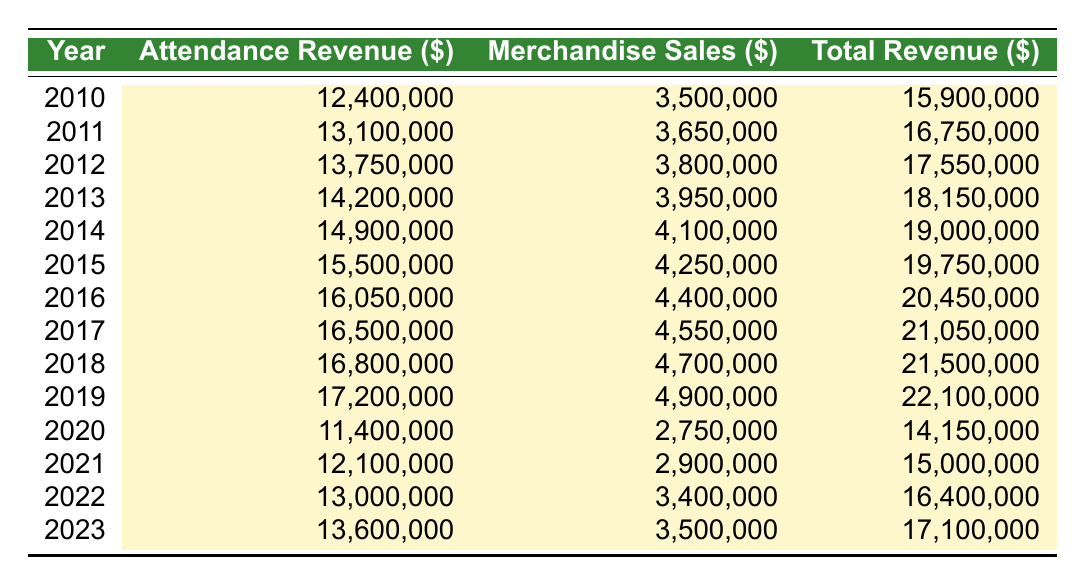What was the total revenue for the Ducks in 2015? The total revenue for the Ducks in 2015 is directly listed in the table. According to the data for 2015, the total revenue is 19,750,000 dollars.
Answer: 19,750,000 Which year saw the highest merchandise sales? By examining the merchandise sales column for each year, we can see that 2019 had the highest sales value of 4,900,000 dollars.
Answer: 2019 What is the difference in attendance revenue between 2010 and 2020? The attendance revenue for 2010 is 12,400,000 dollars and for 2020 it is 11,400,000 dollars. The difference is calculated by subtracting the 2020 value from the 2010 value: 12,400,000 - 11,400,000 = 1,000,000 dollars.
Answer: 1,000,000 What was the average attendance revenue from 2010 to 2019? To calculate the average attendance revenue from 2010 to 2019, we sum the attendance revenues for these years and then divide by the total number of years (10). The sum is: 12,400,000 + 13,100,000 + 13,750,000 + 14,200,000 + 14,900,000 + 15,500,000 + 16,050,000 + 16,500,000 + 16,800,000 + 17,200,000 =  151,450,000. Thus, the average attendance revenue is 151,450,000 / 10 = 15,145,000 dollars.
Answer: 15,145,000 Did the Ducks' total revenue in 2021 exceed that of 2022? Checking the total revenue for both years, in 2021 the total revenue is 15,000,000 dollars and in 2022 it is 16,400,000 dollars. Since 15,000,000 is less than 16,400,000, the statement is false.
Answer: No What was the percentage increase in merchandise sales from 2010 to 2019? To find the percentage increase in merchandise sales, we take the merchandise sales of 2010, which is 3,500,000 dollars, and that of 2019, which is 4,900,000 dollars. The difference is 4,900,000 - 3,500,000 = 1,400,000 dollars. The percentage increase is calculated as (1,400,000 / 3,500,000) * 100, which equals 40 percent.
Answer: 40 percent What was the total revenue over the years 2020 to 2023? To find the total revenue from 2020 to 2023, we add the total revenues for those years. From the table: 14,150,000 (2020) + 15,000,000 (2021) + 16,400,000 (2022) + 17,100,000 (2023) = 62,650,000 dollars.
Answer: 62,650,000 How much did attendance revenue decline from 2019 to 2020? The attendance revenues for 2019 and 2020 are 17,200,000 dollars and 11,400,000 dollars, respectively. The decline is calculated as 17,200,000 - 11,400,000 = 5,800,000 dollars.
Answer: 5,800,000 